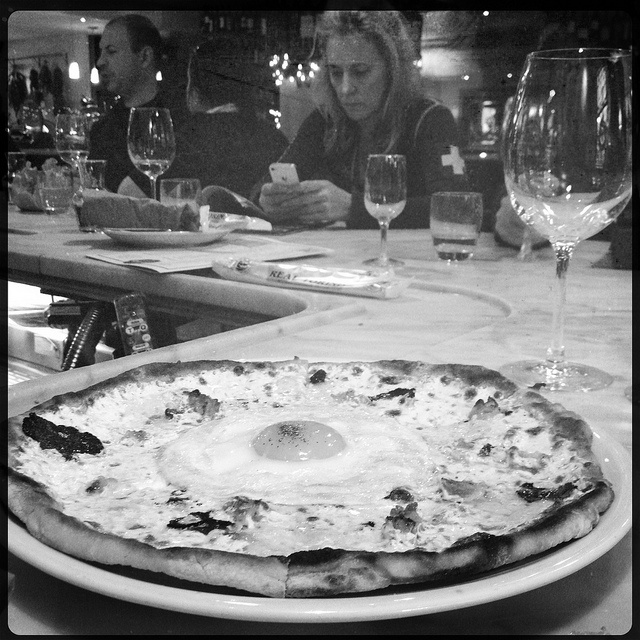Describe the objects in this image and their specific colors. I can see dining table in black, lightgray, darkgray, and gray tones, pizza in black, gainsboro, darkgray, and gray tones, people in black, gray, darkgray, and lightgray tones, wine glass in black, gray, darkgray, and lightgray tones, and people in black, gray, darkgray, and lightgray tones in this image. 